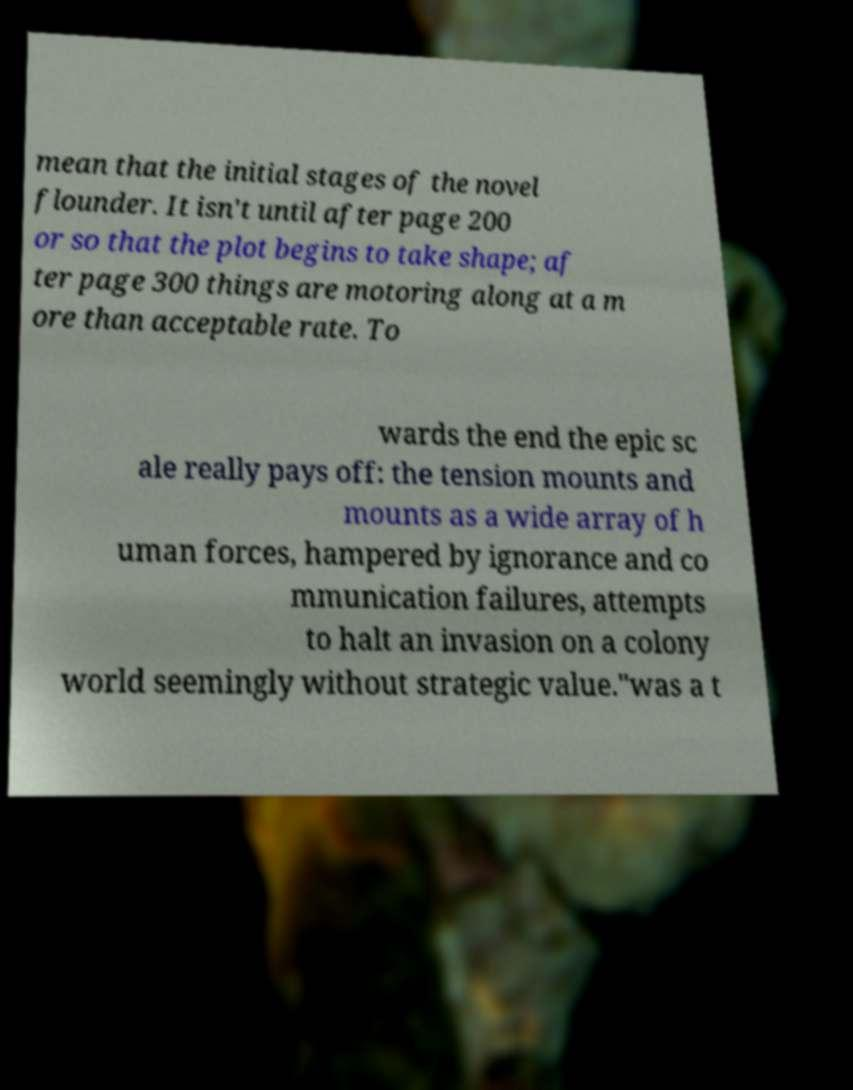Could you assist in decoding the text presented in this image and type it out clearly? mean that the initial stages of the novel flounder. It isn't until after page 200 or so that the plot begins to take shape; af ter page 300 things are motoring along at a m ore than acceptable rate. To wards the end the epic sc ale really pays off: the tension mounts and mounts as a wide array of h uman forces, hampered by ignorance and co mmunication failures, attempts to halt an invasion on a colony world seemingly without strategic value."was a t 